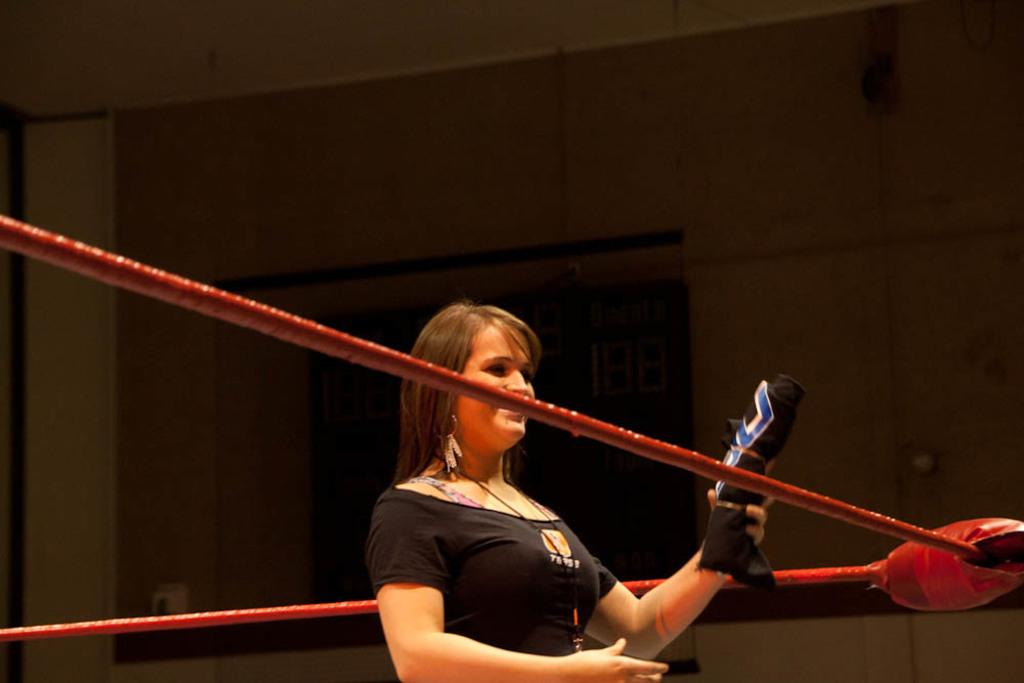Who is present in the image? There is a woman in the image. What is the setting of the image? The woman is in a boxing ring. What is the woman holding in the image? The woman is holding a cloth with her hand. What is the woman's expression in the image? The woman is smiling. What can be seen in the background of the image? There is a wall and a window in the background of the image. What is the rate of the woman's heartbeat in the image? There is no information about the woman's heartbeat in the image, so it cannot be determined. 